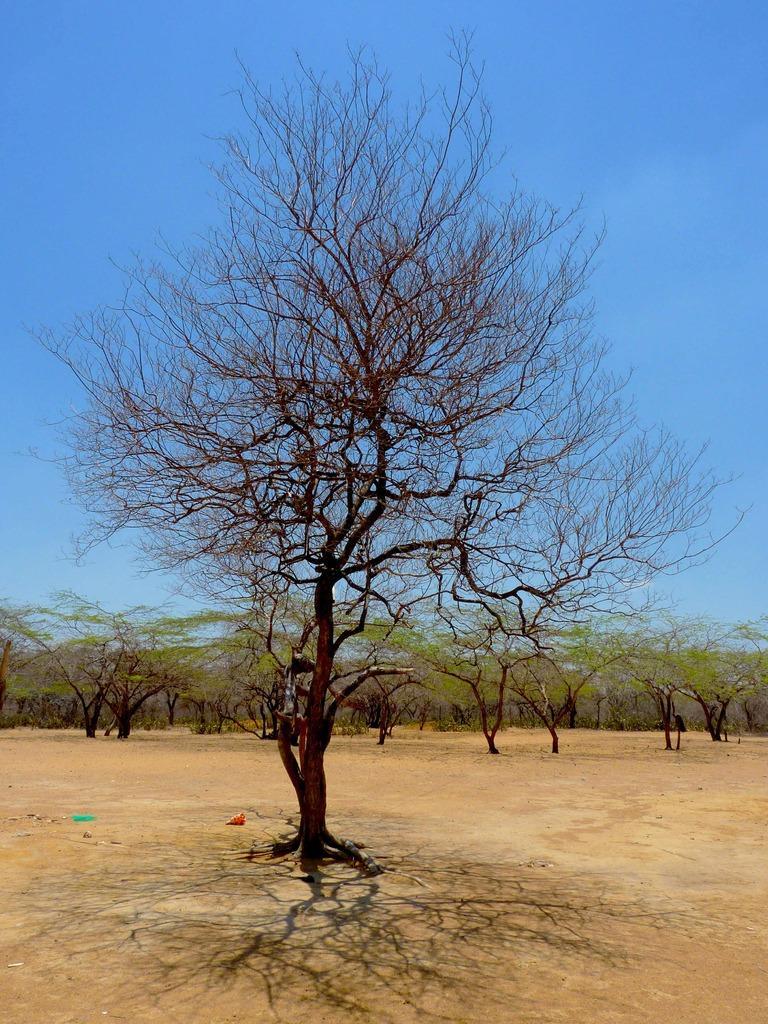Describe this image in one or two sentences. Here we can see trees on surface and sky. 